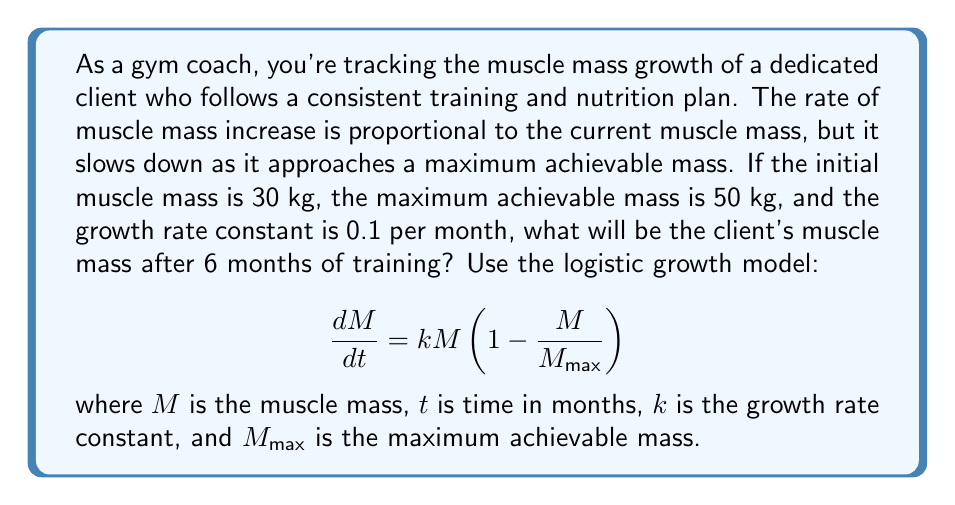Show me your answer to this math problem. Let's solve this step-by-step using the logistic growth model:

1) The logistic growth equation has the solution:

   $$M(t) = \frac{M_{max}}{1 + (\frac{M_{max}}{M_0} - 1)e^{-kt}}$$

   where $M_0$ is the initial muscle mass.

2) We're given:
   $M_0 = 30$ kg
   $M_{max} = 50$ kg
   $k = 0.1$ per month
   $t = 6$ months

3) Let's substitute these values into the equation:

   $$M(6) = \frac{50}{1 + (\frac{50}{30} - 1)e^{-0.1 \cdot 6}}$$

4) Simplify the fraction inside the parentheses:

   $$M(6) = \frac{50}{1 + (\frac{5}{3} - 1)e^{-0.6}}$$

5) Simplify further:

   $$M(6) = \frac{50}{1 + \frac{2}{3}e^{-0.6}}$$

6) Calculate $e^{-0.6}$:

   $$M(6) = \frac{50}{1 + \frac{2}{3} \cdot 0.5488}$$

7) Multiply:

   $$M(6) = \frac{50}{1 + 0.3659}$$

8) Add:

   $$M(6) = \frac{50}{1.3659}$$

9) Divide:

   $$M(6) = 36.61$$ kg (rounded to 2 decimal places)
Answer: 36.61 kg 